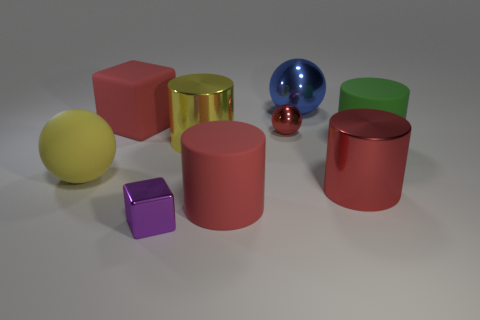What shape is the tiny metallic thing that is the same color as the matte block?
Your answer should be compact. Sphere. Is there another yellow ball that has the same material as the tiny sphere?
Your answer should be compact. No. Is the tiny block made of the same material as the small object right of the large red rubber cylinder?
Keep it short and to the point. Yes. There is another object that is the same size as the purple metallic object; what is its color?
Provide a short and direct response. Red. What is the size of the block right of the red thing on the left side of the tiny metal block?
Ensure brevity in your answer.  Small. Does the rubber sphere have the same color as the large metal cylinder that is on the left side of the tiny red thing?
Provide a short and direct response. Yes. Is the number of small metal spheres in front of the small purple object less than the number of big gray rubber balls?
Provide a succinct answer. No. What number of other things are there of the same size as the purple cube?
Provide a short and direct response. 1. There is a large red matte thing that is right of the red rubber cube; does it have the same shape as the green object?
Your answer should be very brief. Yes. Is the number of tiny metal cubes left of the purple object greater than the number of red metal spheres?
Provide a succinct answer. No. 